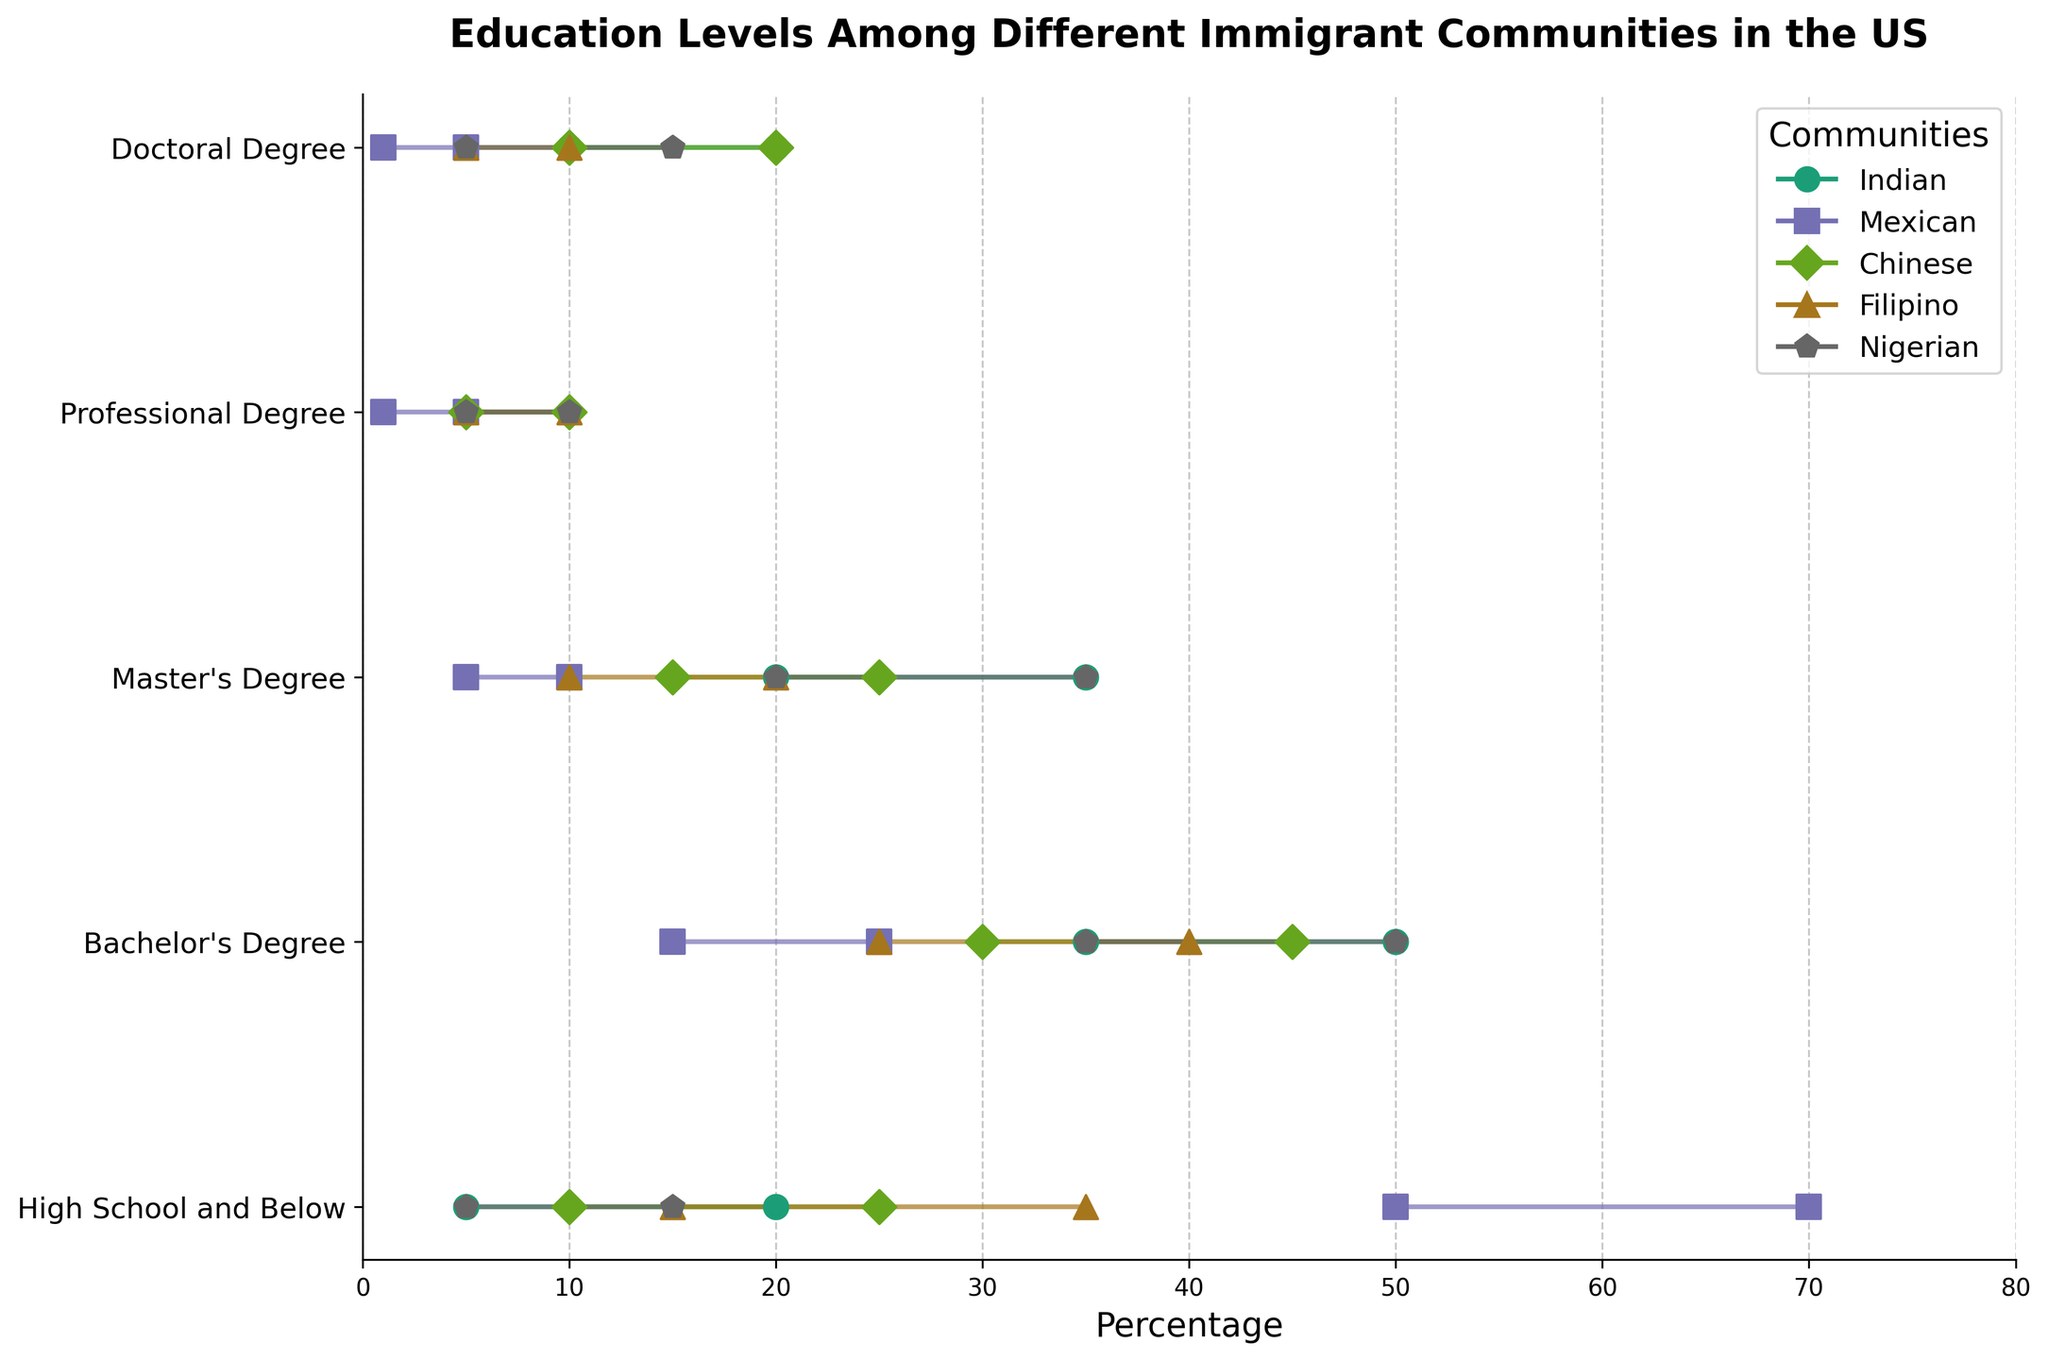What's the title of the plot? The title is usually located at the top of the plot, providing an overview of what the figure represents. In this case, the title at the top reads 'Education Levels Among Different Immigrant Communities in the US'.
Answer: 'Education Levels Among Different Immigrant Communities in the US' Which community has the highest minimum value for 'High School and Below'? To find the highest minimum value for 'High School and Below', check the left endpoint of the bars associated with this category across all communities. The Mexican community has a minimum value of 50, which is the highest.
Answer: 'Mexican' What is the maximum range of percentages for any education level in the Indian community? Look for the longest distance between the minimum and maximum values in each category for the Indian community. The 'Bachelor's Degree' category has a minimum value of 35% and a maximum value of 50%, making the range 50 - 35 = 15.
Answer: '15' Which community has the widest range for the 'Master's Degree' category? Calculate the range for 'Master's Degree' for each community and compare them. The Indian and Nigerian communities both have a range of 15 (35-20), while the others have smaller ranges.
Answer: 'Indian and Nigerian' Compare the maximum percentages for 'Bachelor's Degree' between Filipino and Chinese communities. Which one is higher? Check the right endpoints of the bars for 'Bachelor's Degree' for both Filipino (40%) and Chinese (45%) communities. The Chinese community has a higher maximum percentage.
Answer: 'Chinese' What's the narrowest range for any education level in the Chinese community? Find the smallest difference between minimum and maximum values in each category for the Chinese community. The 'Professional Degree' category has a range of 5 (10-5), which is the narrowest.
Answer: '5' Between the Mexican and Nigerian communities, which one has a higher minimum value for 'Doctoral Degree'? Look at the left endpoints of the bars for 'Doctoral Degree' for both communities. The Nigerian community has a higher minimum value of 5% compared to the Mexican community's 1%.
Answer: 'Nigerian' What's the summed range of percentages for all education levels in the Filipino community? Calculate the range for each category and sum them: 35-15=20, 40-25=15, 20-10=10, 10-5=5, 10-5=5. So, 20 + 15 + 10 + 5 + 5 = 55.
Answer: '55' Which education level shows the least variation in the Indian community? To determine the education level with the least variation, identify the smallest range in the Indian community. The 'Professional Degree' category has the least variation with a range of 5 (10-5).
Answer: 'Professional Degree' For the Chinese community, how many education levels have a maximum percentage greater than 30? Count the number of categories where the maximum value is above 30%. Bachelor's Degree (45%), Master's Degree (25%), and High School and Below (25%) are only the first two categories meeting this criterion.
Answer: '2' 